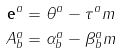Convert formula to latex. <formula><loc_0><loc_0><loc_500><loc_500>\mathbf { e } ^ { a } & = \theta ^ { a } - \tau ^ { a } m \\ A _ { b } ^ { a } & = \alpha _ { b } ^ { a } - \beta _ { b } ^ { a } m</formula> 